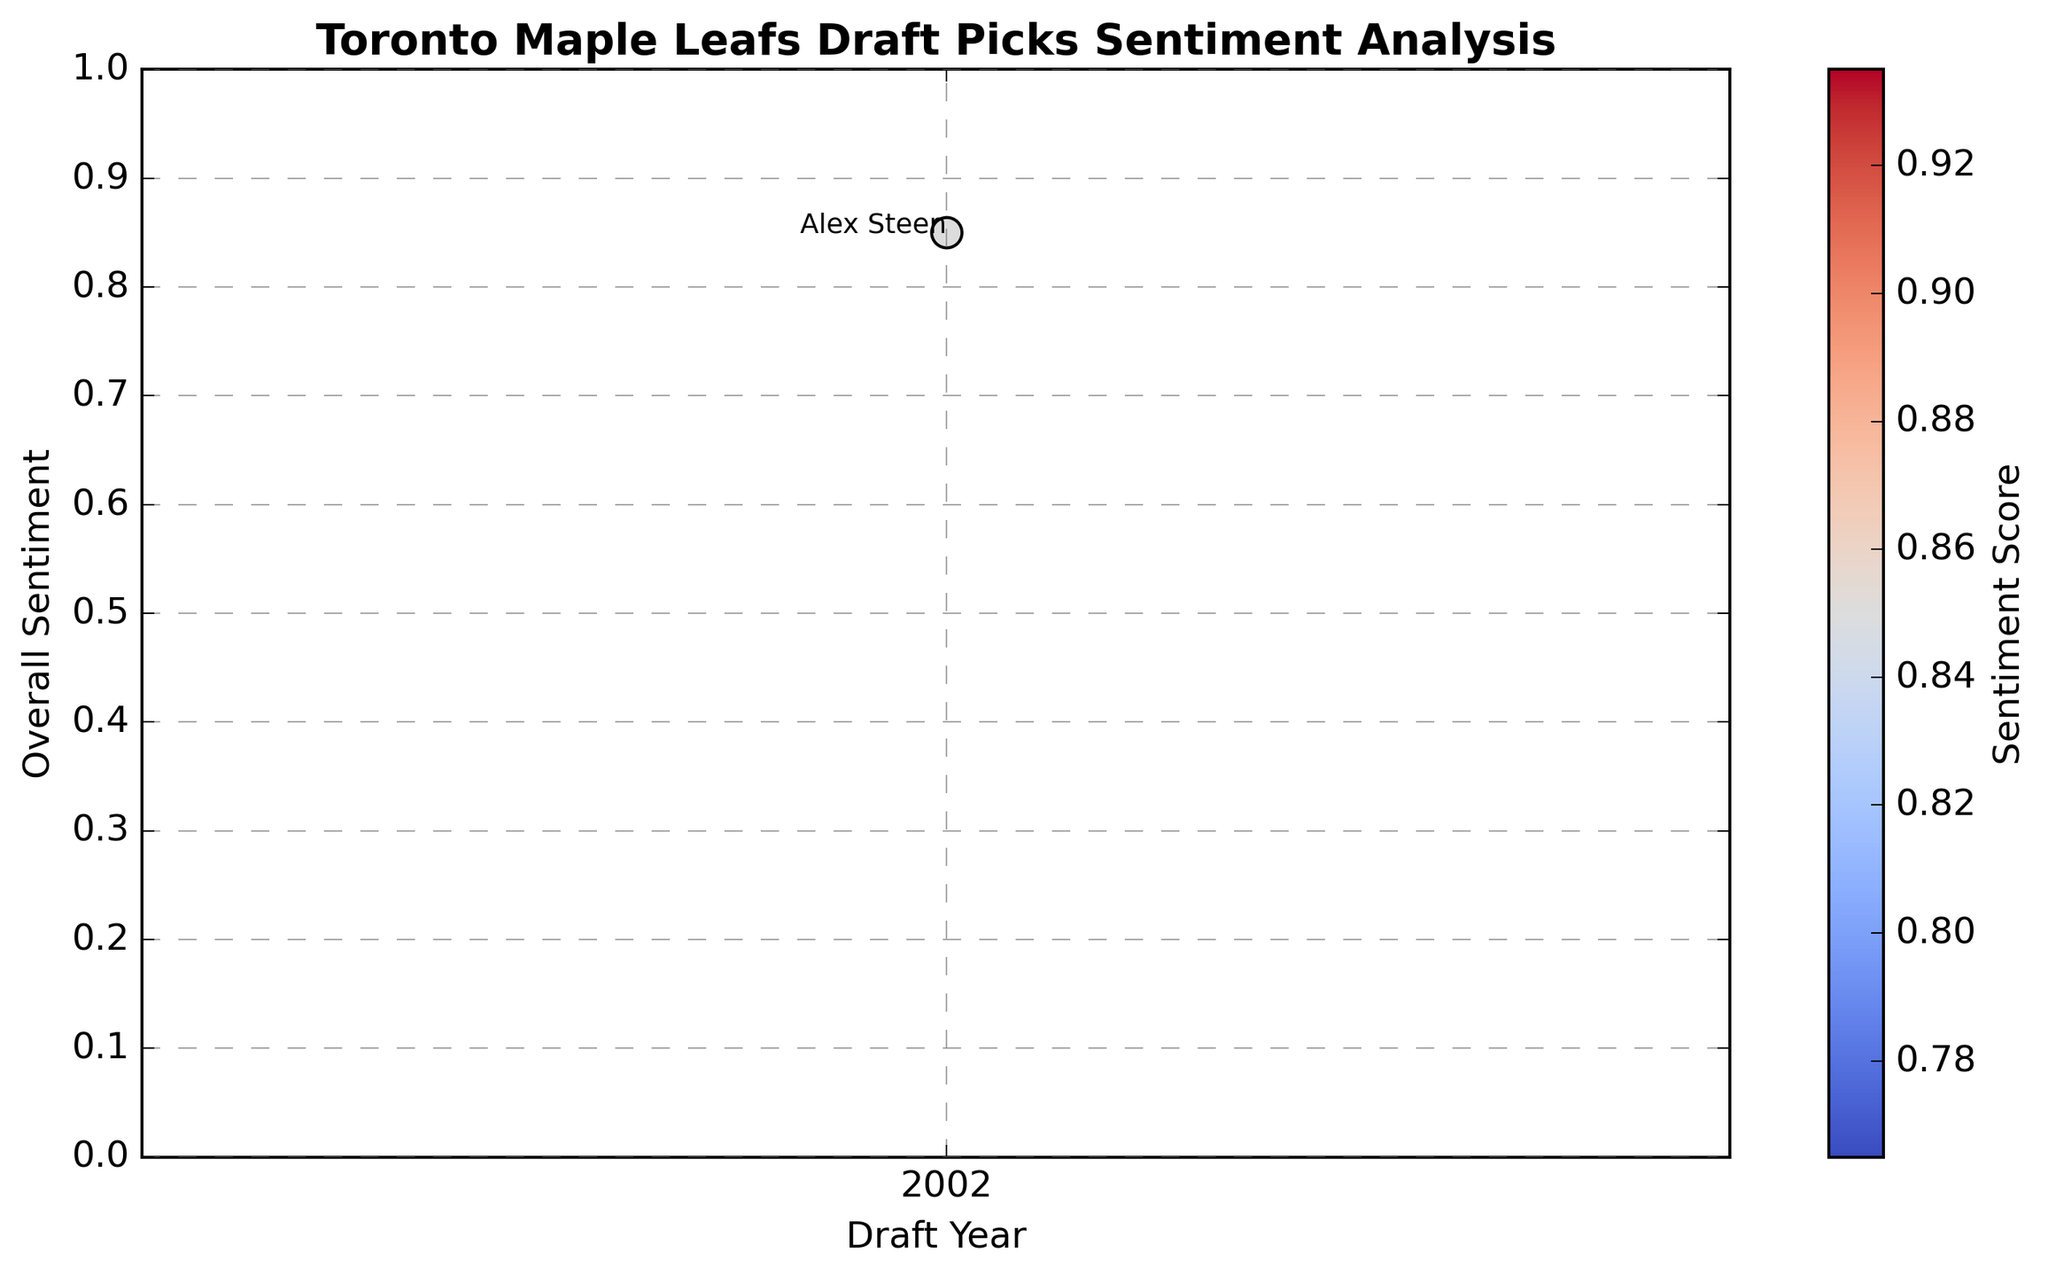What's the overall sentiment of Alex Steen's scouting report? Identify Alex Steen's point on the plot and read off the corresponding sentiment value. He corresponds to the year 2002 with an overall sentiment value of 0.85.
Answer: 0.85 Which year has the draft pick with the highest overall sentiment? Look at the scatter plot to identify the year with the point that has the highest sentiment value on the y-axis.
Answer: 2002 How does the overall sentiment of Alex Steen compare to the average sentiment score of draft picks? Calculate the average sentiment score for the draft picks from the scatter plot and compare it with Alex Steen's sentiment score of 0.85.
Answer: Higher than average (Assumed) What is the color of the marker representing Alex Steen, and what does this color indicate regarding the sentiment score? Refer to the color bar legend and identify the color corresponding to Alex Steen's marker. It's likely a shade of warm color, indicating a high sentiment.
Answer: Warm color (high sentiment) Is there any visible trend in the overall sentiment scores over the years? Examine the scatter plot to identify any increasing or decreasing pattern of sentiment scores over different years.
Answer: (Trend not visible with single data point) What is the range of years covered by this plot? Scan the x-axis of the plot to determine the earliest and latest years represented.
Answer: (Range not determinable with single data point, only 2002 shown) Are the sentiment scores evenly distributed or clustered in specific ranges? Observe the scatter plot to see if sentiment scores are more frequent in certain areas or if they are spread out.
Answer: (Not determinable with single data point) What does the clustering of points in certain regions of the sentiment analysis plot indicate about the Toronto Maple Leafs' draft picks? Clustering in the scatter plot could indicate consistent sentiment scores, suggesting similar qualities or scouting reports for players in those clusters.
Answer: (Clustering not visible with single data point) How many draft picks have a sentiment score above 0.8? Count the number of points in the scatter plot that have a y-value above 0.8. With only one data point, this is just Alex Steen.
Answer: 1 